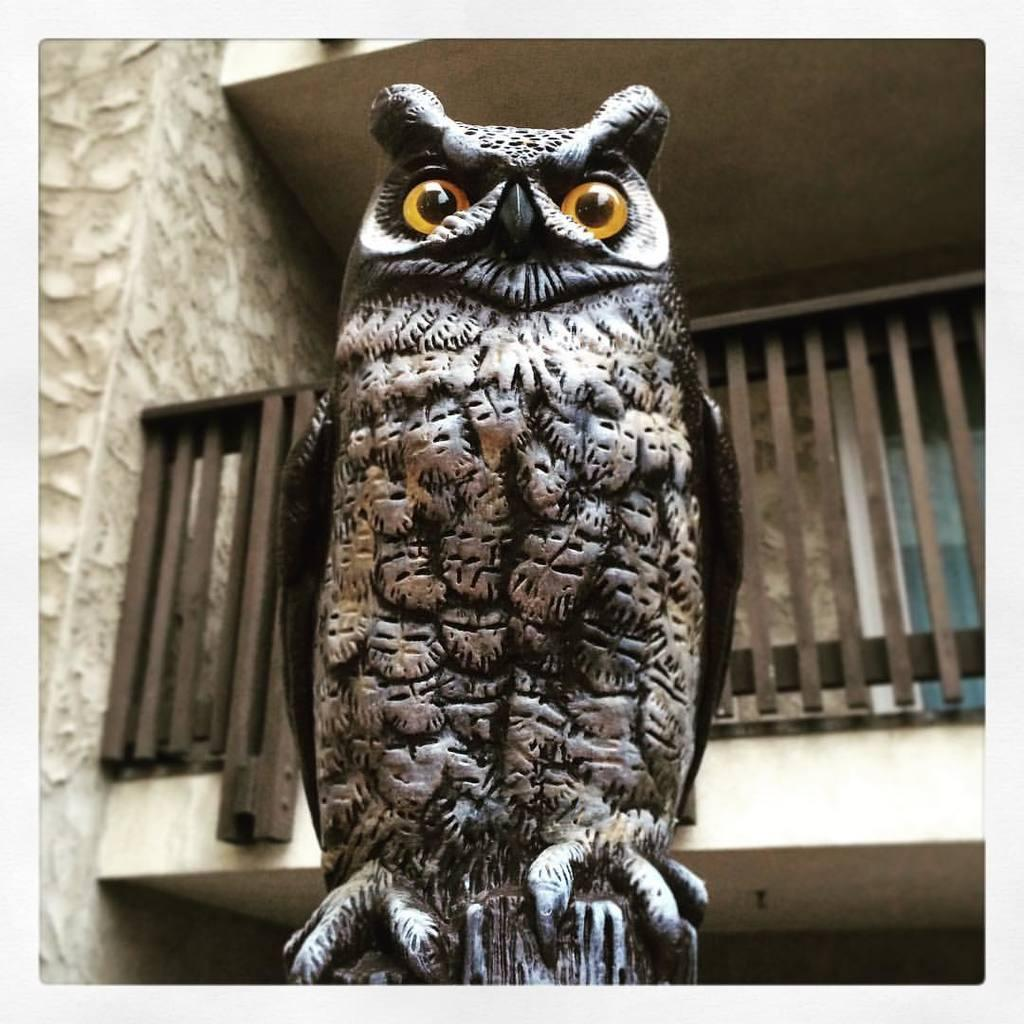What is the main subject of the image? There is a sculpture of an owl in the image. Can you describe the sculpture in more detail? The sculpture is of an owl. What is visible in the background of the image? There is a building with a balcony visible behind the sculpture. What type of sea creatures can be seen swimming near the sculpture in the image? There are no sea creatures visible in the image; it features a sculpture of an owl and a building with a balcony in the background. 